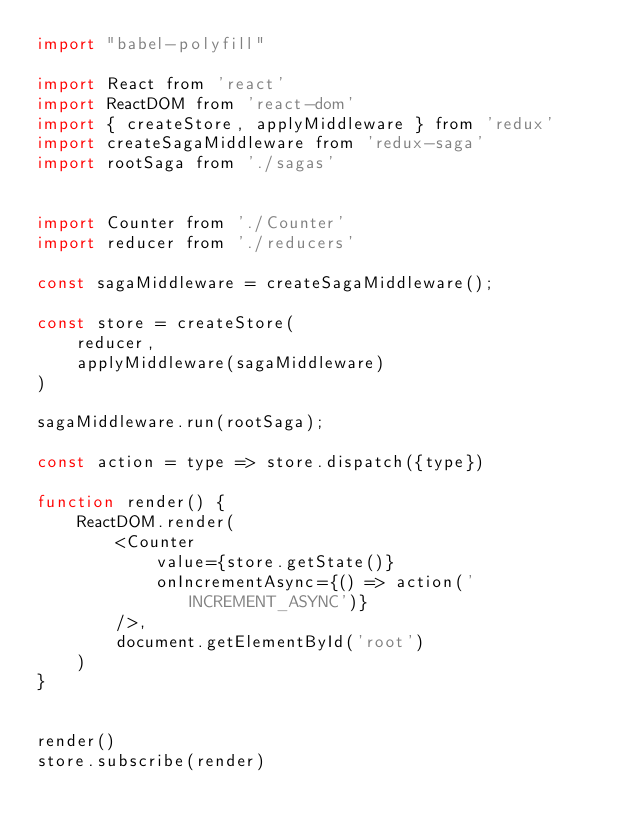<code> <loc_0><loc_0><loc_500><loc_500><_JavaScript_>import "babel-polyfill"

import React from 'react'
import ReactDOM from 'react-dom'
import { createStore, applyMiddleware } from 'redux'
import createSagaMiddleware from 'redux-saga'
import rootSaga from './sagas'


import Counter from './Counter'
import reducer from './reducers'

const sagaMiddleware = createSagaMiddleware();

const store = createStore(
    reducer,
    applyMiddleware(sagaMiddleware)
)

sagaMiddleware.run(rootSaga);

const action = type => store.dispatch({type})

function render() {
    ReactDOM.render(
        <Counter
            value={store.getState()}
            onIncrementAsync={() => action('INCREMENT_ASYNC')}
        />,
        document.getElementById('root')
    )
}


render()
store.subscribe(render)
</code> 